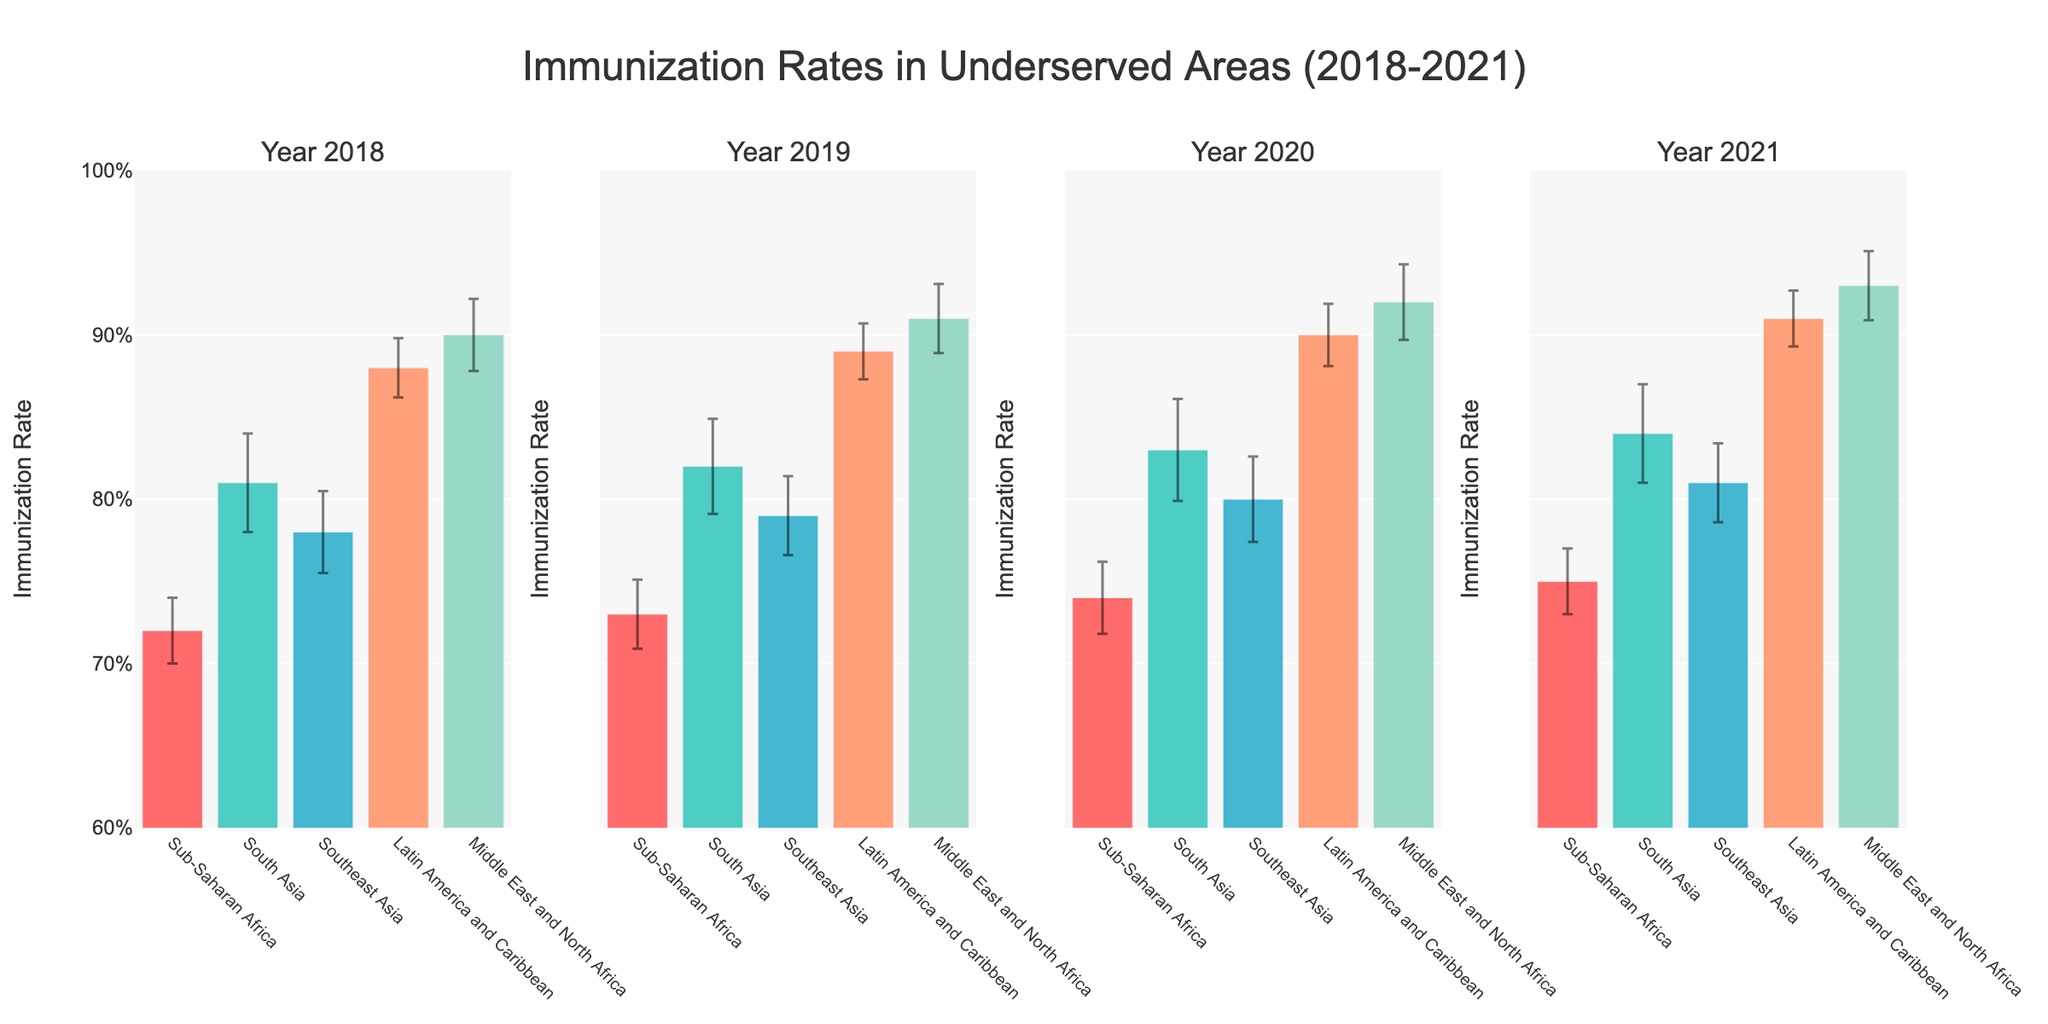What is the title of the figure? The title of the figure can be found at the top center of the chart, usually in a larger font size. In this case, it states "Immunization Rates in Underserved Areas (2018-2021)".
Answer: Immunization Rates in Underserved Areas (2018-2021) What is the immunization rate for Sub-Saharan Africa in 2018? To find the immunization rate for Sub-Saharan Africa in 2018, locate the bar corresponding to Sub-Saharan Africa in the first subplot labeled "Year 2018". The bar height will give the immunization rate.
Answer: 72% Which region had the highest immunization rate in 2021? To determine the region with the highest immunization rate in 2021, look at the last subplot labeled "Year 2021" and identify the tallest bar.
Answer: Middle East and North Africa How did the immunization rate for South Asia change from 2018 to 2021? Compare the bars representing South Asia in the subplots for 2018 and 2021. Note the heights of these bars to determine the rate change.
Answer: Increased from 81% to 84% What is the average immunization rate for Latin America and the Caribbean from 2018 to 2021? Find the immunization rates for Latin America and the Caribbean in all subplots: 88% (2018), 89% (2019), 90% (2020), and 91% (2021). Calculate the average: (88 + 89 + 90 + 91) / 4.
Answer: 89.5% Which year had the lowest immunization rate for Southeast Asia, and what was the rate? Compare the immunization rates for Southeast Asia across all years by looking at the bar heights: 78% (2018), 79% (2019), 80% (2020), and 81% (2021). Identify the lowest rate and the corresponding year.
Answer: 2018, 78% What is the range of immunization rates for Middle East and North Africa from 2018 to 2021? Look at the immunization rates for Middle East and North Africa in each year: 90% (2018), 91% (2019), 92% (2020), and 93% (2021). The range is calculated as the difference between the highest and lowest rates.
Answer: 3% Which region had the smallest error margin in 2020, and what was the value? Look at the error margins for each region in the subplot labeled "Year 2020". The region with the smallest margin will have the shortest error bar.
Answer: Latin America and Caribbean, 1.9% Did any region have a consistent increase in immunization rates from 2018 to 2021? Examine the bars for each region across all years' subplots. Check if the heights of the bars consistently increase from 2018 to 2021 for any region.
Answer: Yes, Middle East and North Africa What is the difference in the immunization rates for Sub-Saharan Africa between 2019 and 2020? Compare the immunization rates for Sub-Saharan Africa in 2019 (73%) and 2020 (74%). Subtract the 2019 rate from the 2020 rate to get the difference.
Answer: 1% 